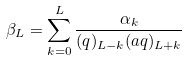Convert formula to latex. <formula><loc_0><loc_0><loc_500><loc_500>\beta _ { L } = \sum _ { k = 0 } ^ { L } \frac { \alpha _ { k } } { ( q ) _ { L - k } ( a q ) _ { L + k } }</formula> 